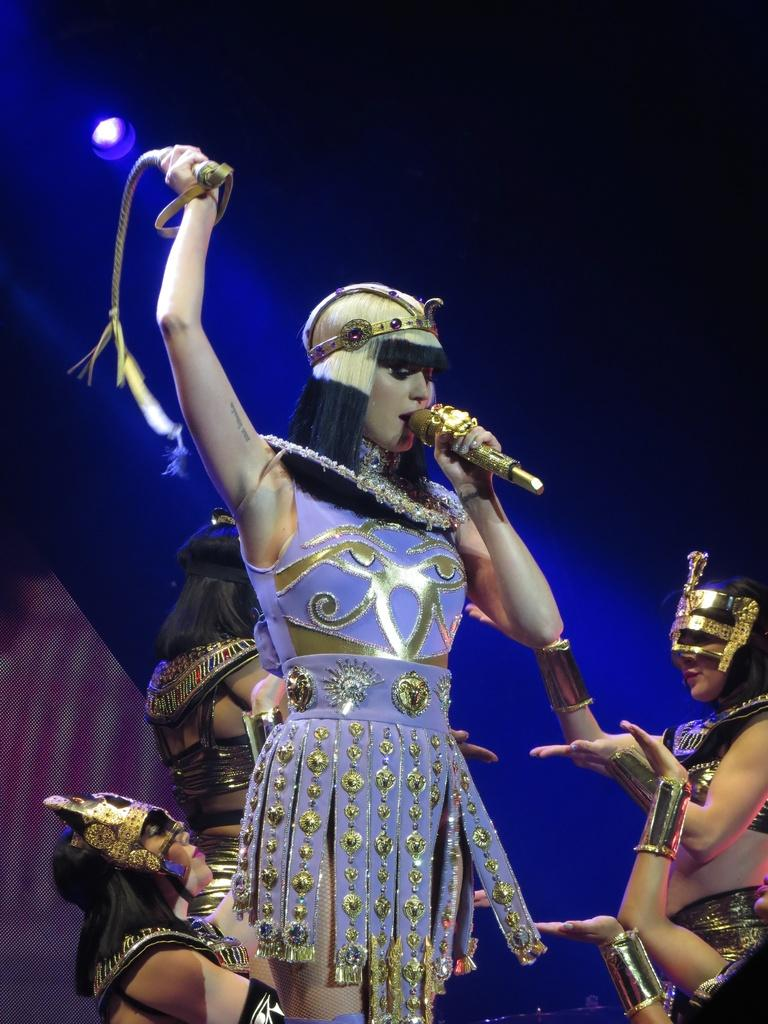Who is the main subject in the image? There is a lady in the image. What object is present in the image that is typically used for amplifying sound? There is a microphone in the image. Can you describe the unspecified object in the image? Unfortunately, the facts provided do not give any details about the unspecified object. What can be seen in the background of the image? There are persons, light, and other objects visible in the background of the image. What type of stick can be seen being used by the group in the image? There is no group or stick present in the image. How does the drain affect the lady's performance in the image? There is no drain present in the image, so it cannot affect the lady's performance. 